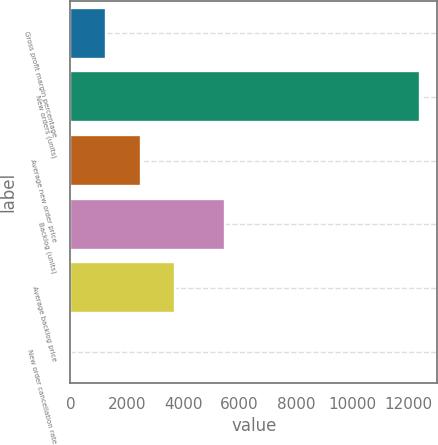Convert chart to OTSL. <chart><loc_0><loc_0><loc_500><loc_500><bar_chart><fcel>Gross profit margin percentage<fcel>New orders (units)<fcel>Average new order price<fcel>Backlog (units)<fcel>Average backlog price<fcel>New order cancellation rate<nl><fcel>1252.04<fcel>12389<fcel>2489.48<fcel>5475<fcel>3726.92<fcel>14.6<nl></chart> 